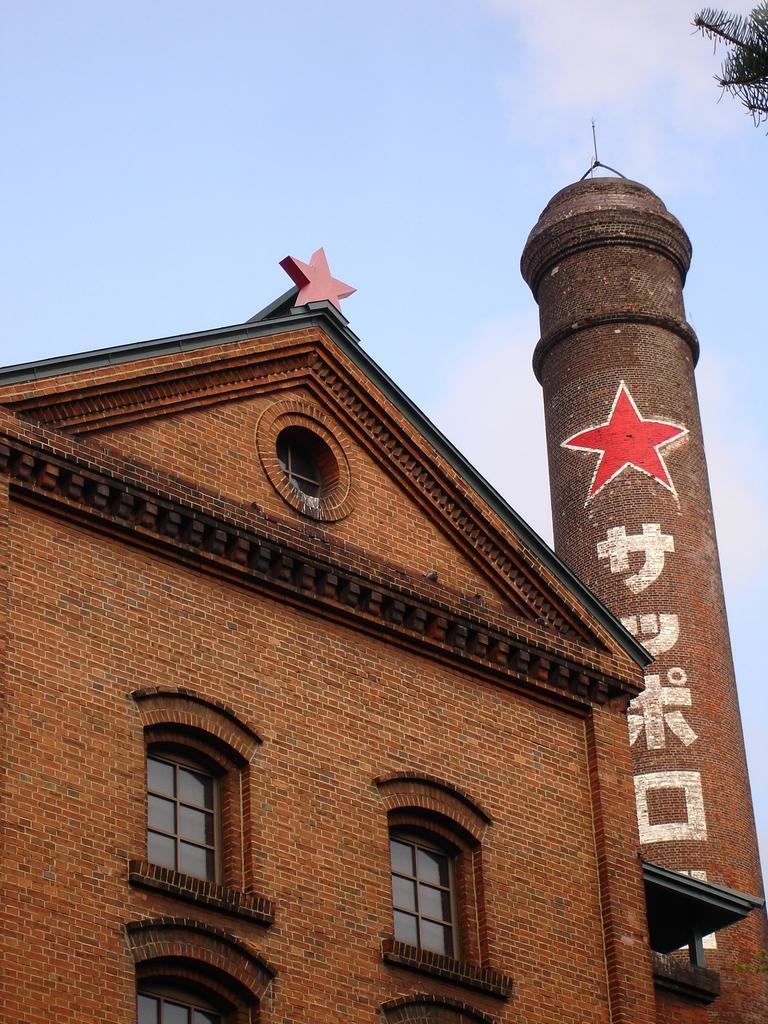Could you give a brief overview of what you see in this image? In the center of the image we can see the sky, branches with leaves, one building, brick wall, some text on the pillar type object, windows and a few other objects. 